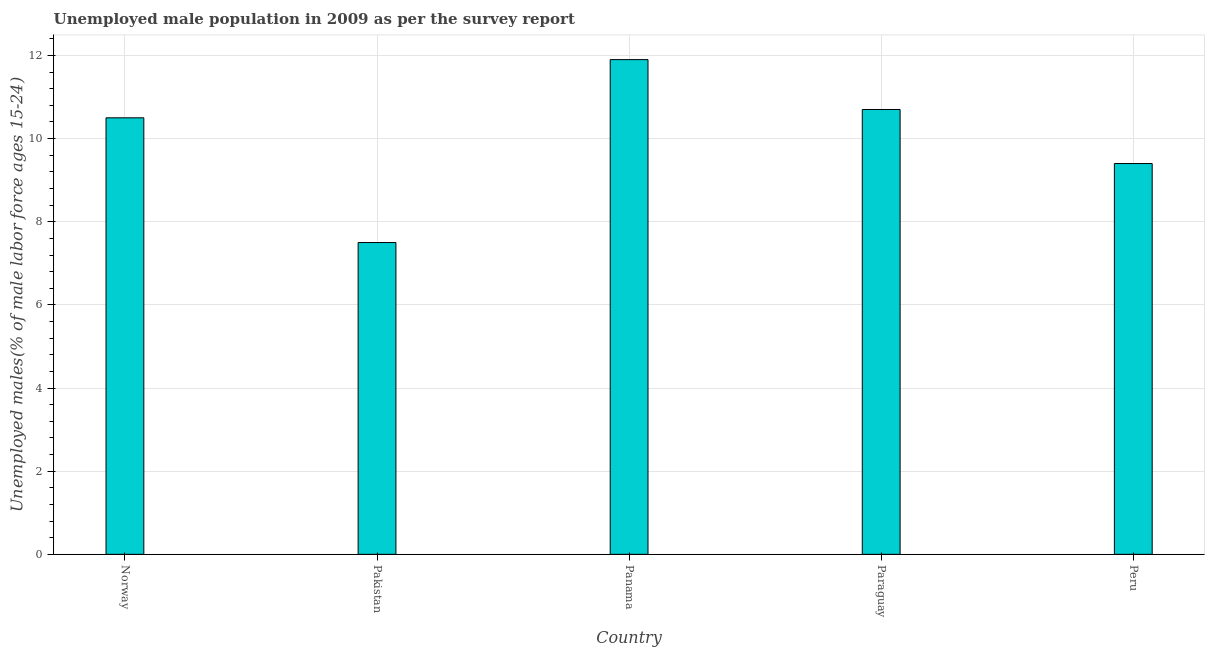Does the graph contain grids?
Your answer should be compact. Yes. What is the title of the graph?
Offer a terse response. Unemployed male population in 2009 as per the survey report. What is the label or title of the X-axis?
Provide a short and direct response. Country. What is the label or title of the Y-axis?
Your response must be concise. Unemployed males(% of male labor force ages 15-24). What is the unemployed male youth in Pakistan?
Provide a short and direct response. 7.5. Across all countries, what is the maximum unemployed male youth?
Your answer should be very brief. 11.9. In which country was the unemployed male youth maximum?
Your response must be concise. Panama. In which country was the unemployed male youth minimum?
Offer a terse response. Pakistan. What is the sum of the unemployed male youth?
Your answer should be very brief. 50. What is the difference between the unemployed male youth in Norway and Paraguay?
Your response must be concise. -0.2. What is the average unemployed male youth per country?
Ensure brevity in your answer.  10. In how many countries, is the unemployed male youth greater than 9.2 %?
Your answer should be very brief. 4. What is the ratio of the unemployed male youth in Pakistan to that in Panama?
Keep it short and to the point. 0.63. Is the unemployed male youth in Pakistan less than that in Paraguay?
Provide a short and direct response. Yes. What is the difference between the highest and the lowest unemployed male youth?
Offer a terse response. 4.4. How many bars are there?
Your response must be concise. 5. What is the difference between two consecutive major ticks on the Y-axis?
Make the answer very short. 2. What is the Unemployed males(% of male labor force ages 15-24) in Norway?
Provide a short and direct response. 10.5. What is the Unemployed males(% of male labor force ages 15-24) of Pakistan?
Ensure brevity in your answer.  7.5. What is the Unemployed males(% of male labor force ages 15-24) in Panama?
Ensure brevity in your answer.  11.9. What is the Unemployed males(% of male labor force ages 15-24) in Paraguay?
Your answer should be very brief. 10.7. What is the Unemployed males(% of male labor force ages 15-24) in Peru?
Your response must be concise. 9.4. What is the difference between the Unemployed males(% of male labor force ages 15-24) in Norway and Panama?
Provide a succinct answer. -1.4. What is the difference between the Unemployed males(% of male labor force ages 15-24) in Norway and Peru?
Your answer should be very brief. 1.1. What is the difference between the Unemployed males(% of male labor force ages 15-24) in Pakistan and Panama?
Your answer should be compact. -4.4. What is the difference between the Unemployed males(% of male labor force ages 15-24) in Panama and Peru?
Your answer should be compact. 2.5. What is the difference between the Unemployed males(% of male labor force ages 15-24) in Paraguay and Peru?
Give a very brief answer. 1.3. What is the ratio of the Unemployed males(% of male labor force ages 15-24) in Norway to that in Pakistan?
Your response must be concise. 1.4. What is the ratio of the Unemployed males(% of male labor force ages 15-24) in Norway to that in Panama?
Give a very brief answer. 0.88. What is the ratio of the Unemployed males(% of male labor force ages 15-24) in Norway to that in Paraguay?
Provide a succinct answer. 0.98. What is the ratio of the Unemployed males(% of male labor force ages 15-24) in Norway to that in Peru?
Provide a short and direct response. 1.12. What is the ratio of the Unemployed males(% of male labor force ages 15-24) in Pakistan to that in Panama?
Offer a very short reply. 0.63. What is the ratio of the Unemployed males(% of male labor force ages 15-24) in Pakistan to that in Paraguay?
Offer a terse response. 0.7. What is the ratio of the Unemployed males(% of male labor force ages 15-24) in Pakistan to that in Peru?
Your answer should be very brief. 0.8. What is the ratio of the Unemployed males(% of male labor force ages 15-24) in Panama to that in Paraguay?
Your answer should be very brief. 1.11. What is the ratio of the Unemployed males(% of male labor force ages 15-24) in Panama to that in Peru?
Provide a short and direct response. 1.27. What is the ratio of the Unemployed males(% of male labor force ages 15-24) in Paraguay to that in Peru?
Offer a terse response. 1.14. 